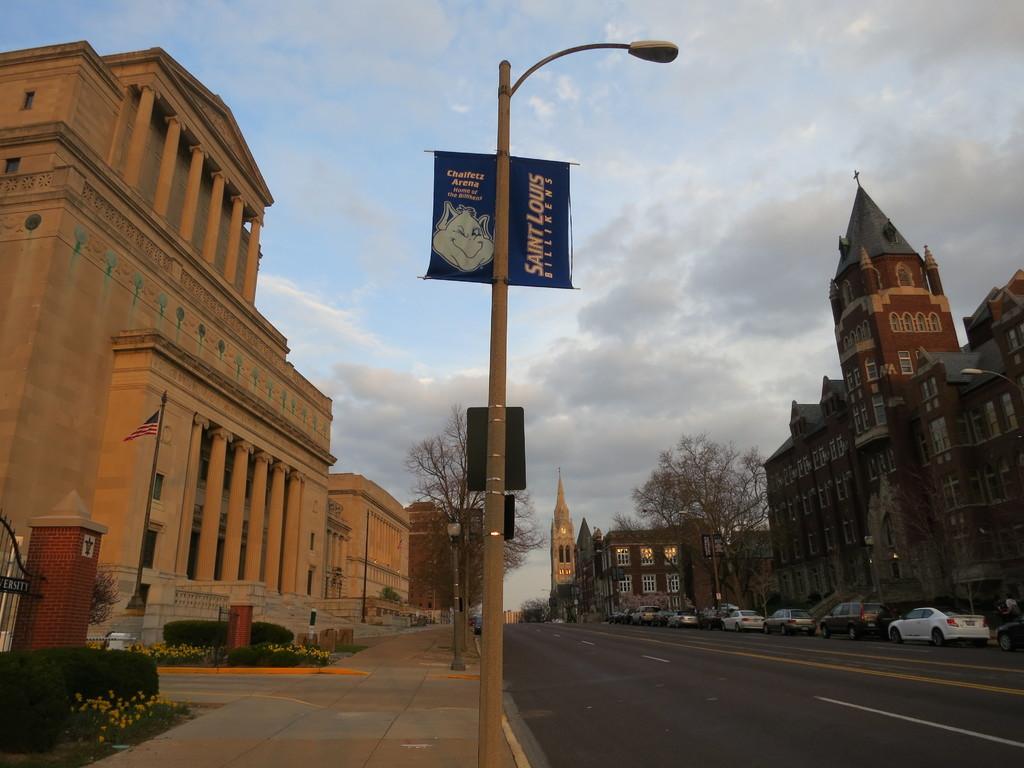Describe this image in one or two sentences. In this picture I can see vehicles on the road, there are buildings, plants, trees, poles, lights, boards, and in the background there is sky. 